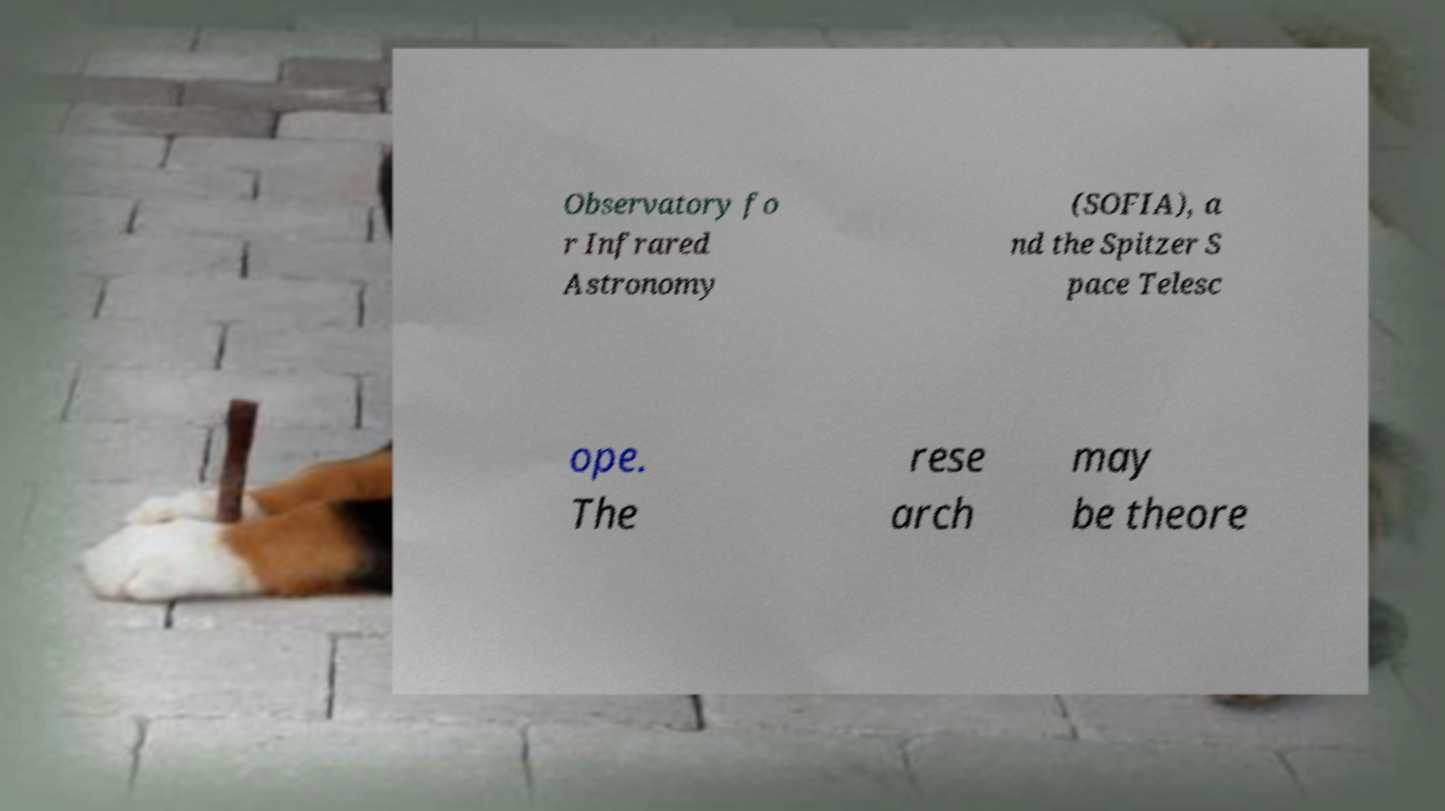What messages or text are displayed in this image? I need them in a readable, typed format. Observatory fo r Infrared Astronomy (SOFIA), a nd the Spitzer S pace Telesc ope. The rese arch may be theore 